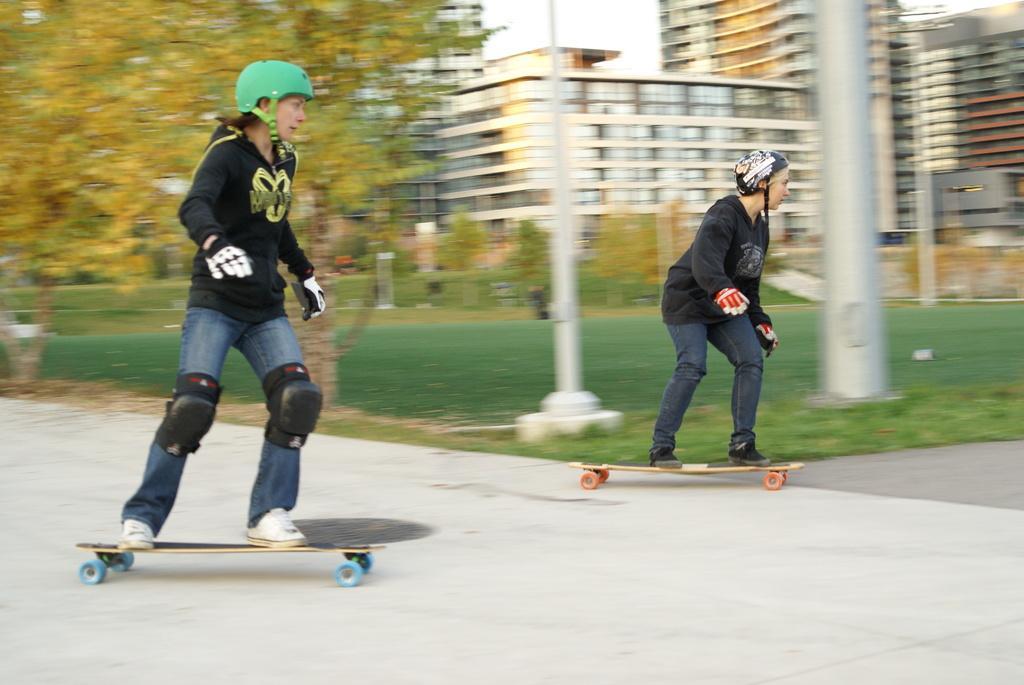Could you give a brief overview of what you see in this image? In this image we can see two persons skating on the road and there are few trees, poles, buildings and the sky in the background. 